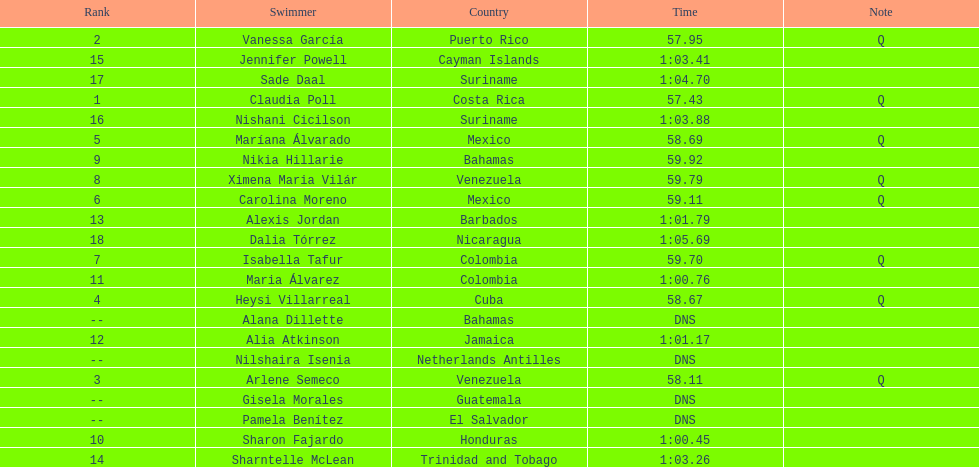How many swimmers had a time of at least 1:00 9. 